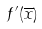Convert formula to latex. <formula><loc_0><loc_0><loc_500><loc_500>f ^ { \prime } ( \overline { x } )</formula> 